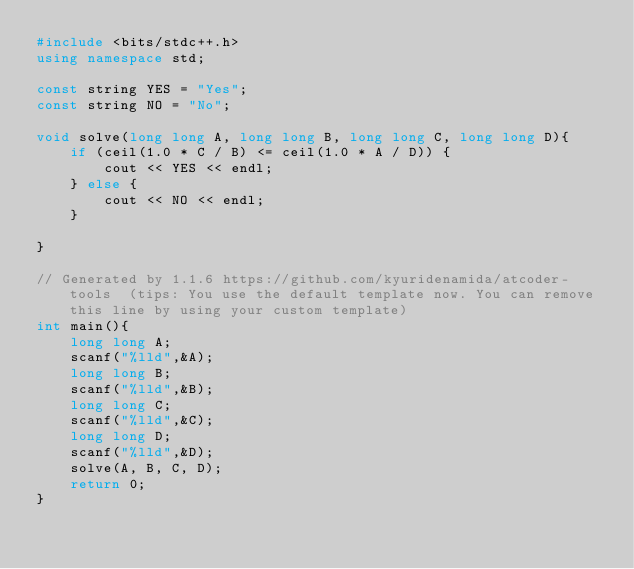Convert code to text. <code><loc_0><loc_0><loc_500><loc_500><_C++_>#include <bits/stdc++.h>
using namespace std;

const string YES = "Yes";
const string NO = "No";

void solve(long long A, long long B, long long C, long long D){
    if (ceil(1.0 * C / B) <= ceil(1.0 * A / D)) {
        cout << YES << endl;
    } else {
        cout << NO << endl;
    }

}

// Generated by 1.1.6 https://github.com/kyuridenamida/atcoder-tools  (tips: You use the default template now. You can remove this line by using your custom template)
int main(){
    long long A;
    scanf("%lld",&A);
    long long B;
    scanf("%lld",&B);
    long long C;
    scanf("%lld",&C);
    long long D;
    scanf("%lld",&D);
    solve(A, B, C, D);
    return 0;
}
</code> 